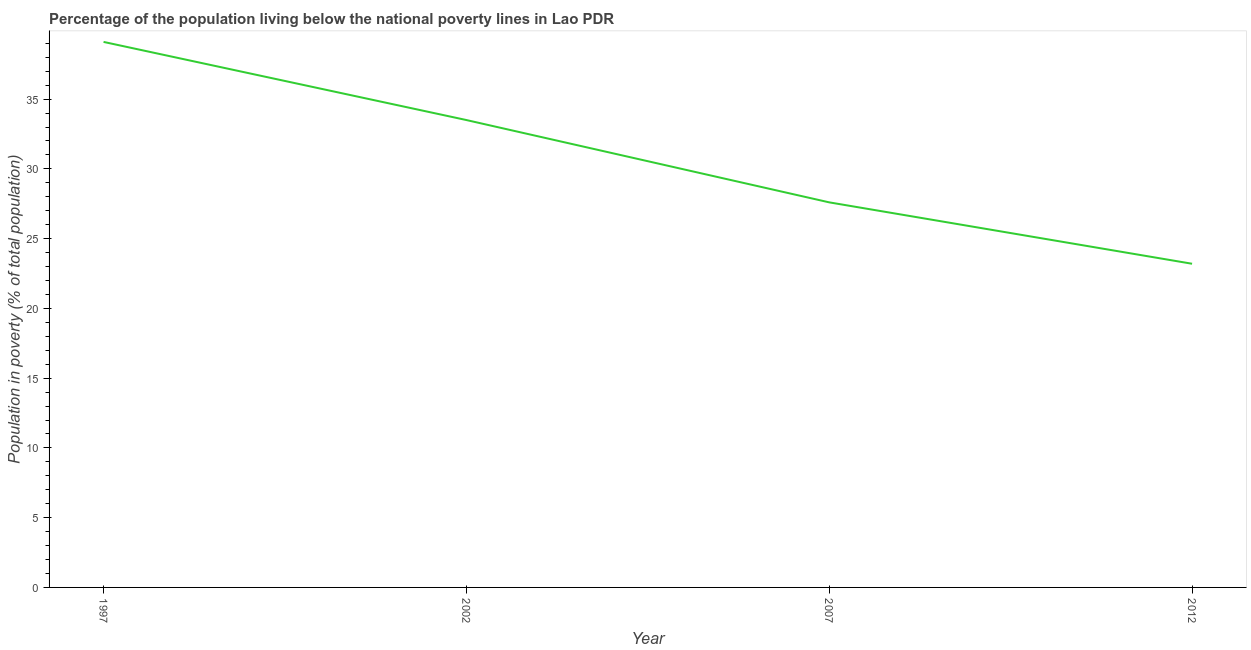What is the percentage of population living below poverty line in 2002?
Your answer should be very brief. 33.5. Across all years, what is the maximum percentage of population living below poverty line?
Offer a very short reply. 39.1. Across all years, what is the minimum percentage of population living below poverty line?
Ensure brevity in your answer.  23.2. In which year was the percentage of population living below poverty line maximum?
Provide a short and direct response. 1997. In which year was the percentage of population living below poverty line minimum?
Your response must be concise. 2012. What is the sum of the percentage of population living below poverty line?
Ensure brevity in your answer.  123.4. What is the difference between the percentage of population living below poverty line in 1997 and 2012?
Offer a terse response. 15.9. What is the average percentage of population living below poverty line per year?
Provide a short and direct response. 30.85. What is the median percentage of population living below poverty line?
Make the answer very short. 30.55. Do a majority of the years between 2002 and 2007 (inclusive) have percentage of population living below poverty line greater than 15 %?
Offer a very short reply. Yes. What is the ratio of the percentage of population living below poverty line in 2002 to that in 2007?
Make the answer very short. 1.21. What is the difference between the highest and the second highest percentage of population living below poverty line?
Your answer should be very brief. 5.6. What is the difference between the highest and the lowest percentage of population living below poverty line?
Offer a terse response. 15.9. In how many years, is the percentage of population living below poverty line greater than the average percentage of population living below poverty line taken over all years?
Keep it short and to the point. 2. Does the percentage of population living below poverty line monotonically increase over the years?
Give a very brief answer. No. How many lines are there?
Your answer should be very brief. 1. How many years are there in the graph?
Your answer should be very brief. 4. What is the difference between two consecutive major ticks on the Y-axis?
Provide a short and direct response. 5. Does the graph contain any zero values?
Give a very brief answer. No. What is the title of the graph?
Ensure brevity in your answer.  Percentage of the population living below the national poverty lines in Lao PDR. What is the label or title of the X-axis?
Your answer should be very brief. Year. What is the label or title of the Y-axis?
Your response must be concise. Population in poverty (% of total population). What is the Population in poverty (% of total population) of 1997?
Your answer should be compact. 39.1. What is the Population in poverty (% of total population) of 2002?
Keep it short and to the point. 33.5. What is the Population in poverty (% of total population) of 2007?
Your response must be concise. 27.6. What is the Population in poverty (% of total population) of 2012?
Offer a very short reply. 23.2. What is the difference between the Population in poverty (% of total population) in 1997 and 2012?
Make the answer very short. 15.9. What is the ratio of the Population in poverty (% of total population) in 1997 to that in 2002?
Provide a short and direct response. 1.17. What is the ratio of the Population in poverty (% of total population) in 1997 to that in 2007?
Your response must be concise. 1.42. What is the ratio of the Population in poverty (% of total population) in 1997 to that in 2012?
Offer a terse response. 1.69. What is the ratio of the Population in poverty (% of total population) in 2002 to that in 2007?
Give a very brief answer. 1.21. What is the ratio of the Population in poverty (% of total population) in 2002 to that in 2012?
Provide a short and direct response. 1.44. What is the ratio of the Population in poverty (% of total population) in 2007 to that in 2012?
Provide a succinct answer. 1.19. 